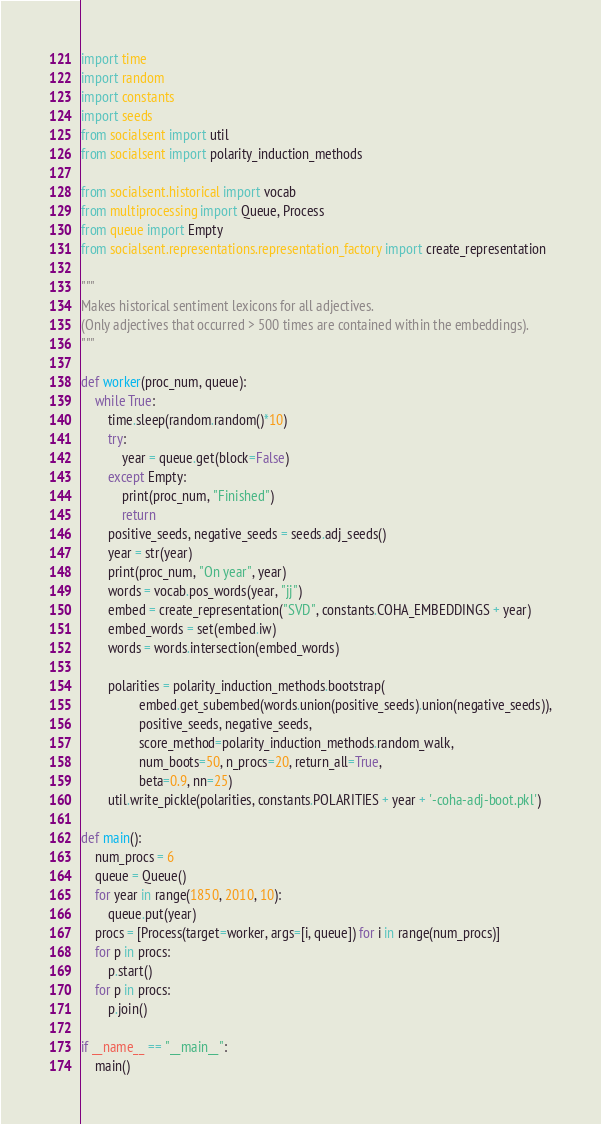<code> <loc_0><loc_0><loc_500><loc_500><_Python_>import time
import random
import constants
import seeds
from socialsent import util
from socialsent import polarity_induction_methods

from socialsent.historical import vocab
from multiprocessing import Queue, Process
from queue import Empty
from socialsent.representations.representation_factory import create_representation

"""
Makes historical sentiment lexicons for all adjectives.
(Only adjectives that occurred > 500 times are contained within the embeddings).
"""

def worker(proc_num, queue):
    while True:
        time.sleep(random.random()*10)
        try:
            year = queue.get(block=False)
        except Empty:
            print(proc_num, "Finished")
            return
        positive_seeds, negative_seeds = seeds.adj_seeds()
        year = str(year)
        print(proc_num, "On year", year)
        words = vocab.pos_words(year, "jj")
        embed = create_representation("SVD", constants.COHA_EMBEDDINGS + year)
        embed_words = set(embed.iw)
        words = words.intersection(embed_words)

        polarities = polarity_induction_methods.bootstrap(
                 embed.get_subembed(words.union(positive_seeds).union(negative_seeds)),
                 positive_seeds, negative_seeds,
                 score_method=polarity_induction_methods.random_walk,
                 num_boots=50, n_procs=20, return_all=True,
                 beta=0.9, nn=25)
        util.write_pickle(polarities, constants.POLARITIES + year + '-coha-adj-boot.pkl')

def main():
    num_procs = 6
    queue = Queue()
    for year in range(1850, 2010, 10):
        queue.put(year)
    procs = [Process(target=worker, args=[i, queue]) for i in range(num_procs)]
    for p in procs:
        p.start()
    for p in procs:
        p.join()

if __name__ == "__main__":
    main()
</code> 